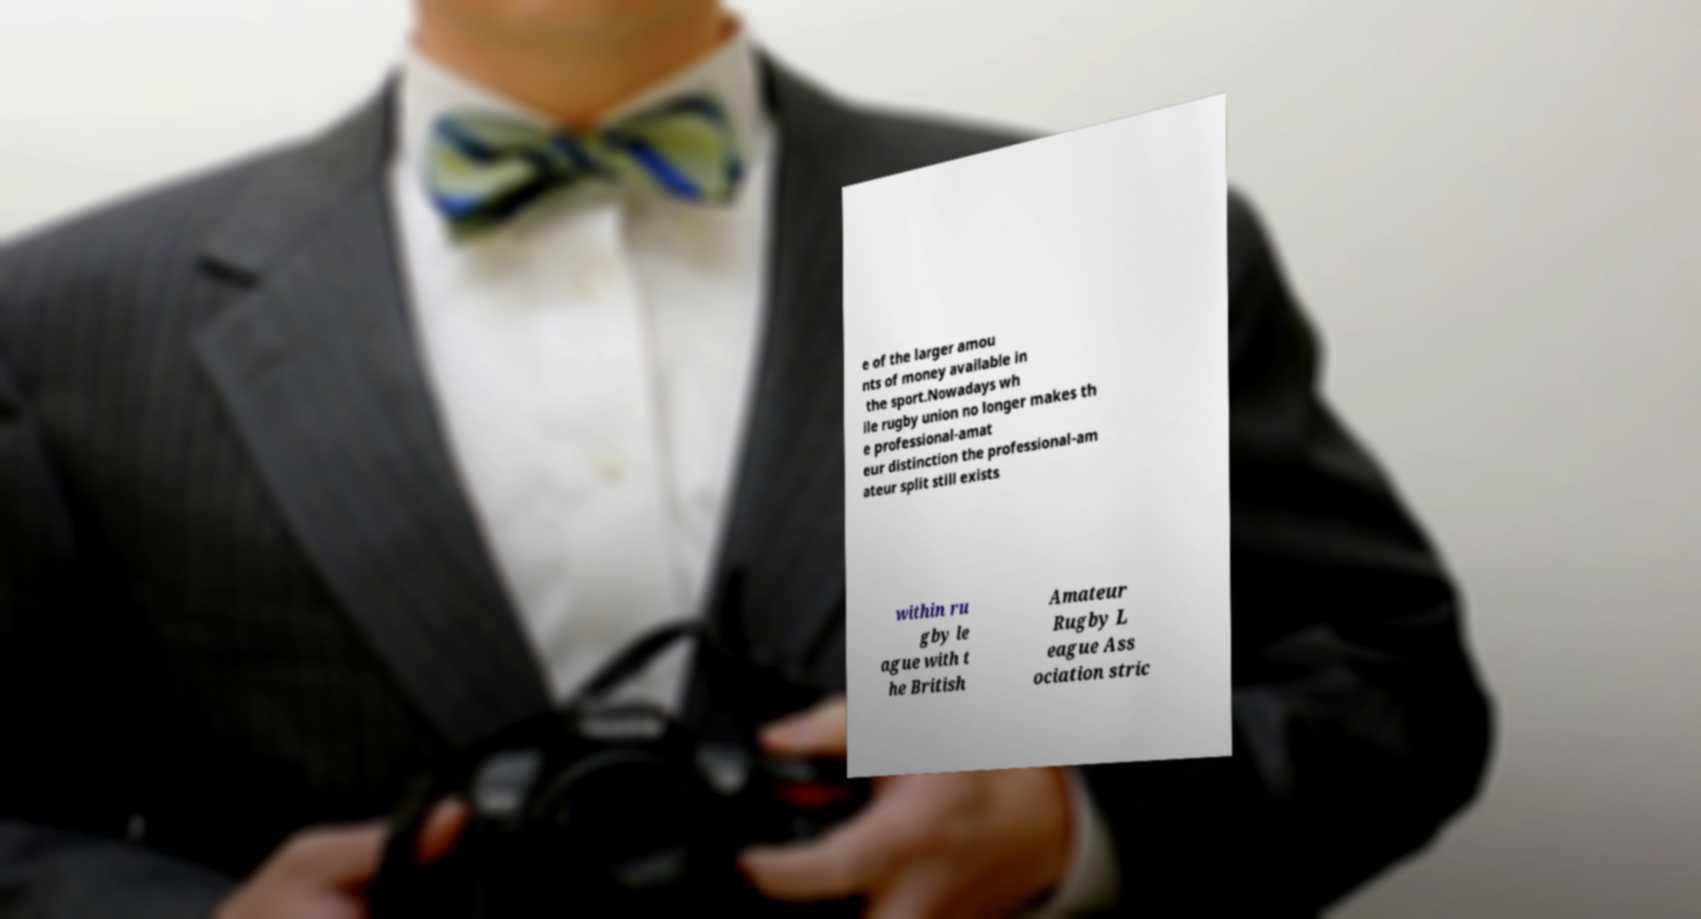Please read and relay the text visible in this image. What does it say? e of the larger amou nts of money available in the sport.Nowadays wh ile rugby union no longer makes th e professional-amat eur distinction the professional-am ateur split still exists within ru gby le ague with t he British Amateur Rugby L eague Ass ociation stric 